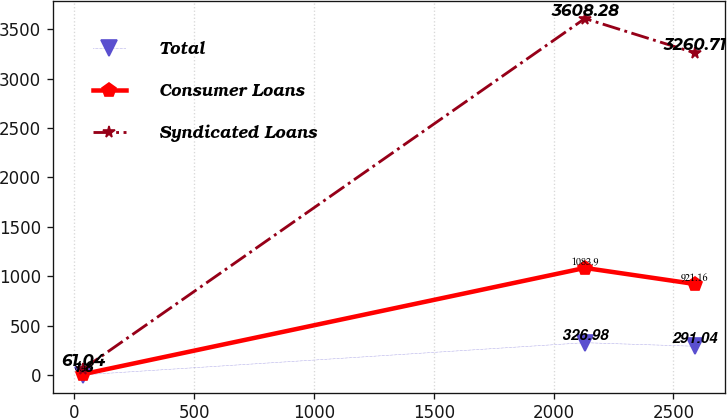Convert chart. <chart><loc_0><loc_0><loc_500><loc_500><line_chart><ecel><fcel>Total<fcel>Consumer Loans<fcel>Syndicated Loans<nl><fcel>36.6<fcel>1.8<fcel>8.48<fcel>61.04<nl><fcel>2130.39<fcel>326.98<fcel>1083.9<fcel>3608.28<nl><fcel>2588.77<fcel>291.04<fcel>921.16<fcel>3260.71<nl></chart> 